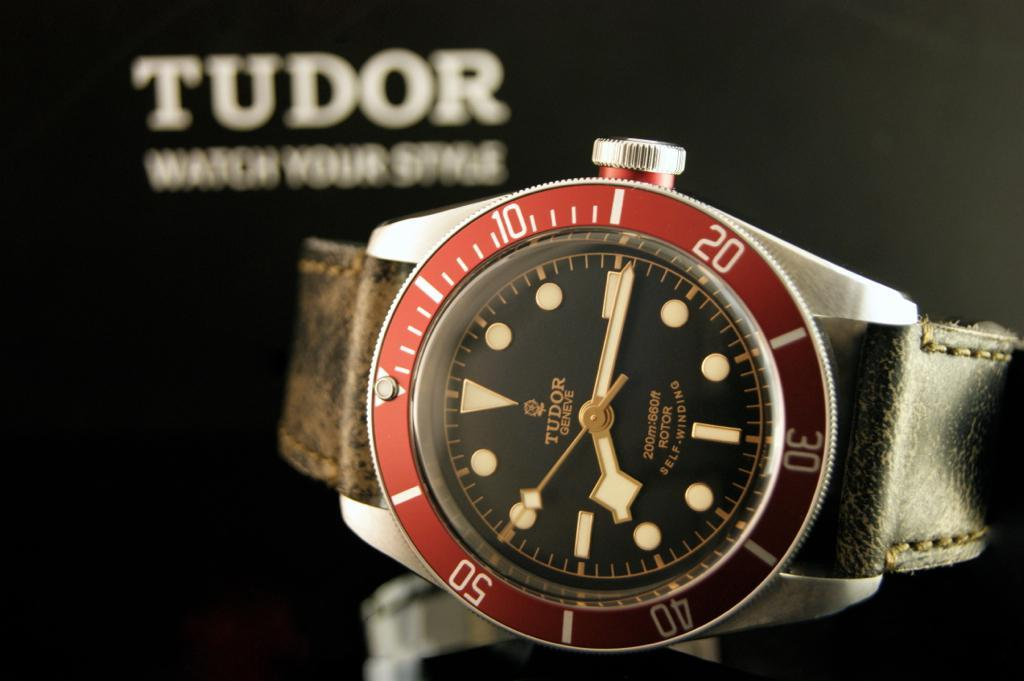<image>
Give a short and clear explanation of the subsequent image. Face of a watch which has the word TUDOR on it. 